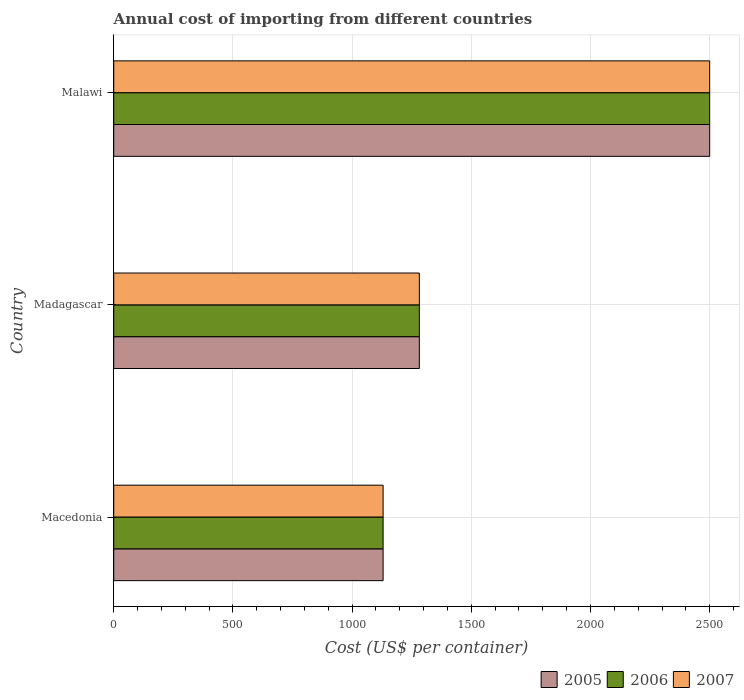Are the number of bars per tick equal to the number of legend labels?
Keep it short and to the point. Yes. What is the label of the 2nd group of bars from the top?
Keep it short and to the point. Madagascar. In how many cases, is the number of bars for a given country not equal to the number of legend labels?
Give a very brief answer. 0. What is the total annual cost of importing in 2005 in Macedonia?
Ensure brevity in your answer.  1130. Across all countries, what is the maximum total annual cost of importing in 2005?
Give a very brief answer. 2500. Across all countries, what is the minimum total annual cost of importing in 2006?
Your response must be concise. 1130. In which country was the total annual cost of importing in 2005 maximum?
Provide a short and direct response. Malawi. In which country was the total annual cost of importing in 2006 minimum?
Provide a short and direct response. Macedonia. What is the total total annual cost of importing in 2005 in the graph?
Your answer should be very brief. 4912. What is the difference between the total annual cost of importing in 2005 in Macedonia and that in Malawi?
Keep it short and to the point. -1370. What is the difference between the total annual cost of importing in 2006 in Madagascar and the total annual cost of importing in 2005 in Macedonia?
Keep it short and to the point. 152. What is the average total annual cost of importing in 2006 per country?
Your answer should be very brief. 1637.33. In how many countries, is the total annual cost of importing in 2007 greater than 1400 US$?
Offer a terse response. 1. What is the ratio of the total annual cost of importing in 2006 in Madagascar to that in Malawi?
Your response must be concise. 0.51. What is the difference between the highest and the second highest total annual cost of importing in 2005?
Offer a very short reply. 1218. What is the difference between the highest and the lowest total annual cost of importing in 2006?
Your answer should be very brief. 1370. Is the sum of the total annual cost of importing in 2005 in Macedonia and Madagascar greater than the maximum total annual cost of importing in 2007 across all countries?
Ensure brevity in your answer.  No. What does the 1st bar from the top in Madagascar represents?
Your answer should be compact. 2007. What does the 2nd bar from the bottom in Madagascar represents?
Your response must be concise. 2006. How many bars are there?
Give a very brief answer. 9. How many countries are there in the graph?
Your answer should be compact. 3. What is the difference between two consecutive major ticks on the X-axis?
Give a very brief answer. 500. Where does the legend appear in the graph?
Provide a short and direct response. Bottom right. How are the legend labels stacked?
Your response must be concise. Horizontal. What is the title of the graph?
Offer a very short reply. Annual cost of importing from different countries. Does "1992" appear as one of the legend labels in the graph?
Make the answer very short. No. What is the label or title of the X-axis?
Your response must be concise. Cost (US$ per container). What is the label or title of the Y-axis?
Offer a terse response. Country. What is the Cost (US$ per container) in 2005 in Macedonia?
Offer a very short reply. 1130. What is the Cost (US$ per container) of 2006 in Macedonia?
Your answer should be very brief. 1130. What is the Cost (US$ per container) in 2007 in Macedonia?
Keep it short and to the point. 1130. What is the Cost (US$ per container) in 2005 in Madagascar?
Provide a short and direct response. 1282. What is the Cost (US$ per container) in 2006 in Madagascar?
Provide a short and direct response. 1282. What is the Cost (US$ per container) in 2007 in Madagascar?
Ensure brevity in your answer.  1282. What is the Cost (US$ per container) in 2005 in Malawi?
Offer a terse response. 2500. What is the Cost (US$ per container) in 2006 in Malawi?
Your answer should be very brief. 2500. What is the Cost (US$ per container) in 2007 in Malawi?
Give a very brief answer. 2500. Across all countries, what is the maximum Cost (US$ per container) in 2005?
Your answer should be very brief. 2500. Across all countries, what is the maximum Cost (US$ per container) of 2006?
Provide a succinct answer. 2500. Across all countries, what is the maximum Cost (US$ per container) in 2007?
Your answer should be compact. 2500. Across all countries, what is the minimum Cost (US$ per container) of 2005?
Your response must be concise. 1130. Across all countries, what is the minimum Cost (US$ per container) of 2006?
Keep it short and to the point. 1130. Across all countries, what is the minimum Cost (US$ per container) in 2007?
Your answer should be compact. 1130. What is the total Cost (US$ per container) of 2005 in the graph?
Provide a short and direct response. 4912. What is the total Cost (US$ per container) in 2006 in the graph?
Your answer should be compact. 4912. What is the total Cost (US$ per container) in 2007 in the graph?
Keep it short and to the point. 4912. What is the difference between the Cost (US$ per container) in 2005 in Macedonia and that in Madagascar?
Ensure brevity in your answer.  -152. What is the difference between the Cost (US$ per container) in 2006 in Macedonia and that in Madagascar?
Your answer should be very brief. -152. What is the difference between the Cost (US$ per container) in 2007 in Macedonia and that in Madagascar?
Your answer should be very brief. -152. What is the difference between the Cost (US$ per container) of 2005 in Macedonia and that in Malawi?
Offer a terse response. -1370. What is the difference between the Cost (US$ per container) in 2006 in Macedonia and that in Malawi?
Make the answer very short. -1370. What is the difference between the Cost (US$ per container) of 2007 in Macedonia and that in Malawi?
Your answer should be compact. -1370. What is the difference between the Cost (US$ per container) in 2005 in Madagascar and that in Malawi?
Give a very brief answer. -1218. What is the difference between the Cost (US$ per container) in 2006 in Madagascar and that in Malawi?
Your answer should be very brief. -1218. What is the difference between the Cost (US$ per container) in 2007 in Madagascar and that in Malawi?
Your answer should be very brief. -1218. What is the difference between the Cost (US$ per container) of 2005 in Macedonia and the Cost (US$ per container) of 2006 in Madagascar?
Your response must be concise. -152. What is the difference between the Cost (US$ per container) in 2005 in Macedonia and the Cost (US$ per container) in 2007 in Madagascar?
Ensure brevity in your answer.  -152. What is the difference between the Cost (US$ per container) of 2006 in Macedonia and the Cost (US$ per container) of 2007 in Madagascar?
Offer a terse response. -152. What is the difference between the Cost (US$ per container) of 2005 in Macedonia and the Cost (US$ per container) of 2006 in Malawi?
Offer a very short reply. -1370. What is the difference between the Cost (US$ per container) of 2005 in Macedonia and the Cost (US$ per container) of 2007 in Malawi?
Offer a very short reply. -1370. What is the difference between the Cost (US$ per container) of 2006 in Macedonia and the Cost (US$ per container) of 2007 in Malawi?
Your answer should be very brief. -1370. What is the difference between the Cost (US$ per container) in 2005 in Madagascar and the Cost (US$ per container) in 2006 in Malawi?
Offer a terse response. -1218. What is the difference between the Cost (US$ per container) of 2005 in Madagascar and the Cost (US$ per container) of 2007 in Malawi?
Keep it short and to the point. -1218. What is the difference between the Cost (US$ per container) in 2006 in Madagascar and the Cost (US$ per container) in 2007 in Malawi?
Give a very brief answer. -1218. What is the average Cost (US$ per container) of 2005 per country?
Your answer should be very brief. 1637.33. What is the average Cost (US$ per container) in 2006 per country?
Your answer should be very brief. 1637.33. What is the average Cost (US$ per container) of 2007 per country?
Ensure brevity in your answer.  1637.33. What is the difference between the Cost (US$ per container) of 2005 and Cost (US$ per container) of 2007 in Macedonia?
Offer a very short reply. 0. What is the difference between the Cost (US$ per container) of 2005 and Cost (US$ per container) of 2006 in Madagascar?
Provide a succinct answer. 0. What is the difference between the Cost (US$ per container) in 2005 and Cost (US$ per container) in 2007 in Madagascar?
Ensure brevity in your answer.  0. What is the difference between the Cost (US$ per container) of 2006 and Cost (US$ per container) of 2007 in Madagascar?
Ensure brevity in your answer.  0. What is the difference between the Cost (US$ per container) in 2005 and Cost (US$ per container) in 2006 in Malawi?
Offer a very short reply. 0. What is the difference between the Cost (US$ per container) of 2005 and Cost (US$ per container) of 2007 in Malawi?
Provide a short and direct response. 0. What is the ratio of the Cost (US$ per container) of 2005 in Macedonia to that in Madagascar?
Your response must be concise. 0.88. What is the ratio of the Cost (US$ per container) of 2006 in Macedonia to that in Madagascar?
Offer a very short reply. 0.88. What is the ratio of the Cost (US$ per container) in 2007 in Macedonia to that in Madagascar?
Your answer should be very brief. 0.88. What is the ratio of the Cost (US$ per container) in 2005 in Macedonia to that in Malawi?
Give a very brief answer. 0.45. What is the ratio of the Cost (US$ per container) in 2006 in Macedonia to that in Malawi?
Give a very brief answer. 0.45. What is the ratio of the Cost (US$ per container) of 2007 in Macedonia to that in Malawi?
Give a very brief answer. 0.45. What is the ratio of the Cost (US$ per container) in 2005 in Madagascar to that in Malawi?
Give a very brief answer. 0.51. What is the ratio of the Cost (US$ per container) in 2006 in Madagascar to that in Malawi?
Provide a succinct answer. 0.51. What is the ratio of the Cost (US$ per container) in 2007 in Madagascar to that in Malawi?
Your answer should be very brief. 0.51. What is the difference between the highest and the second highest Cost (US$ per container) in 2005?
Provide a succinct answer. 1218. What is the difference between the highest and the second highest Cost (US$ per container) in 2006?
Make the answer very short. 1218. What is the difference between the highest and the second highest Cost (US$ per container) of 2007?
Make the answer very short. 1218. What is the difference between the highest and the lowest Cost (US$ per container) of 2005?
Offer a very short reply. 1370. What is the difference between the highest and the lowest Cost (US$ per container) in 2006?
Offer a terse response. 1370. What is the difference between the highest and the lowest Cost (US$ per container) in 2007?
Give a very brief answer. 1370. 